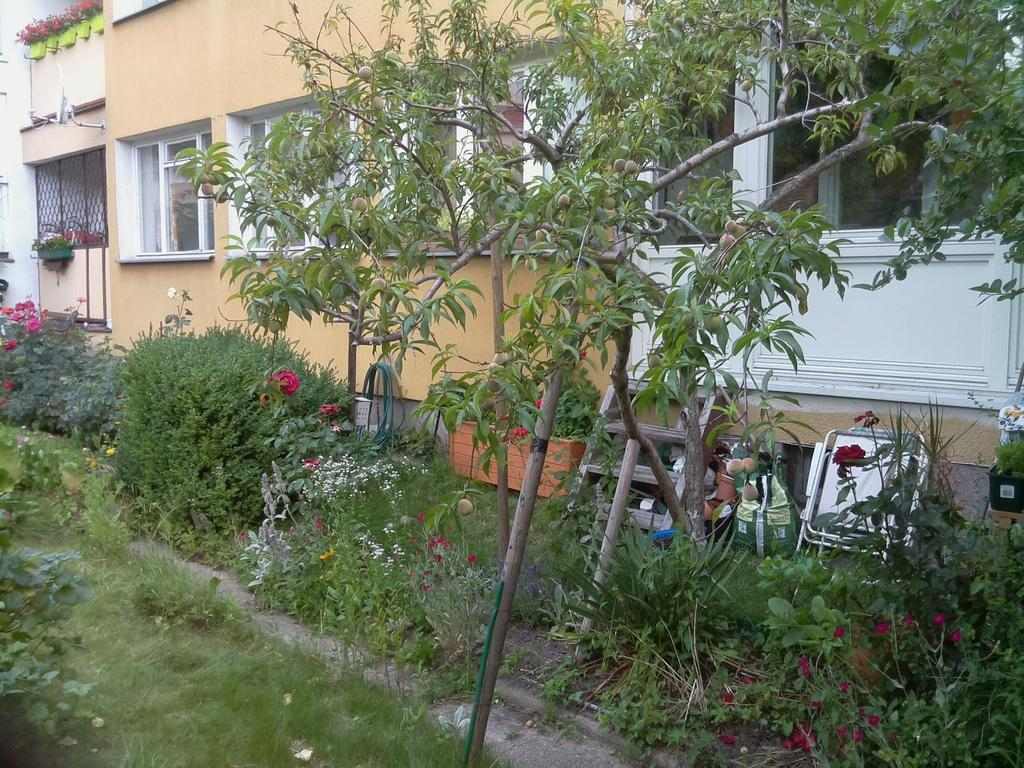What type of vegetation can be seen in the image? There is grass, plants, flowers, and trees visible in the image. What type of structure is present in the background of the image? There is a building in the background of the image. What architectural feature can be seen on the building in the image? There are windows visible in the background of the image. What type of tin is being used to hold the wine in the image? There is no tin or wine present in the image. What type of map can be seen in the image? There is no map present in the image. 